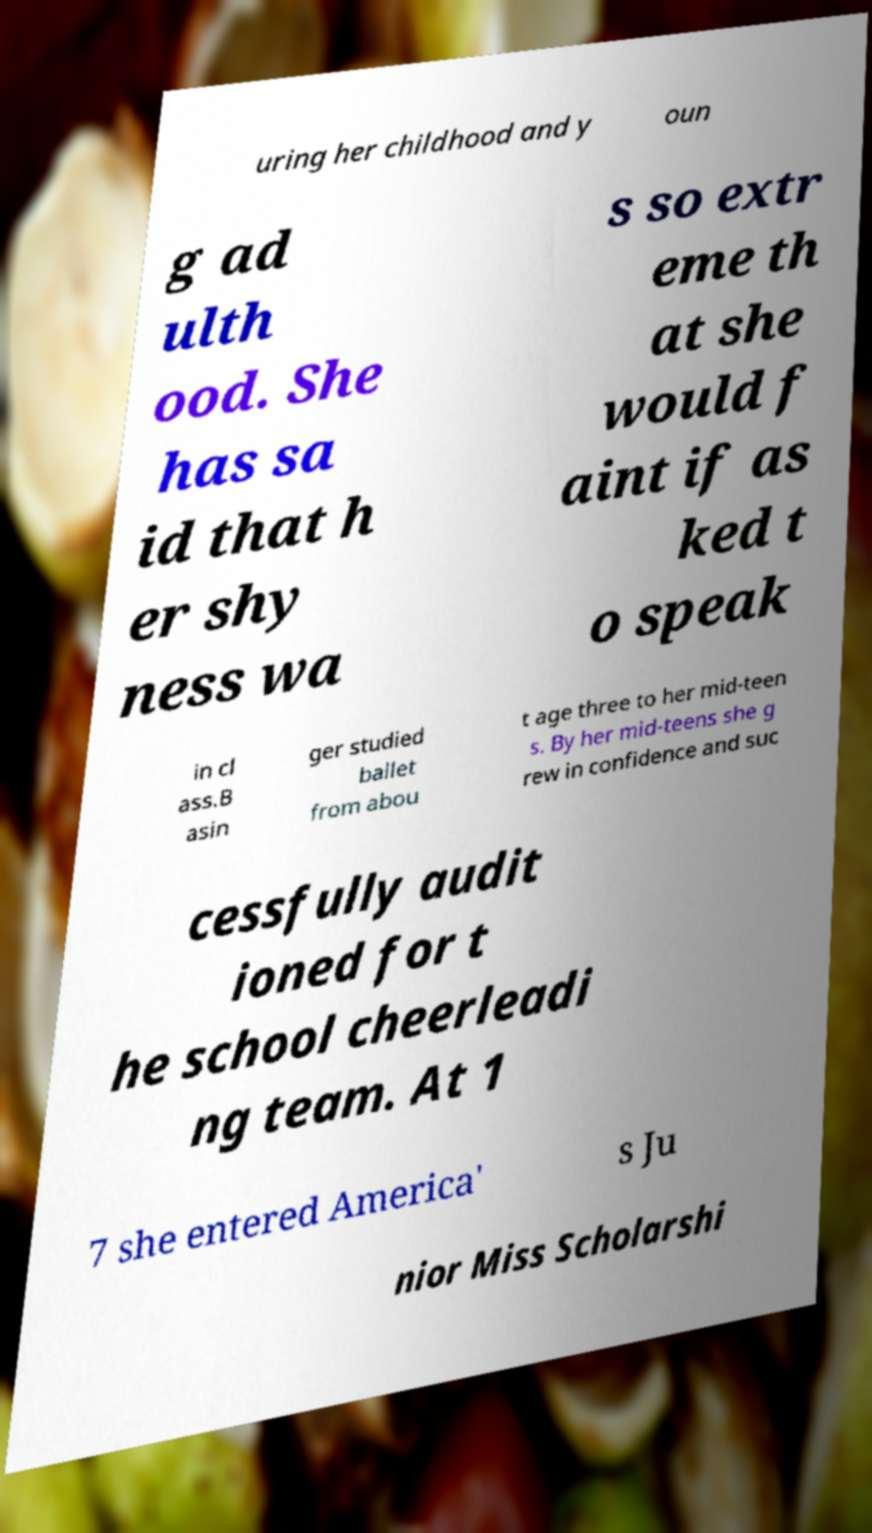Can you read and provide the text displayed in the image?This photo seems to have some interesting text. Can you extract and type it out for me? uring her childhood and y oun g ad ulth ood. She has sa id that h er shy ness wa s so extr eme th at she would f aint if as ked t o speak in cl ass.B asin ger studied ballet from abou t age three to her mid-teen s. By her mid-teens she g rew in confidence and suc cessfully audit ioned for t he school cheerleadi ng team. At 1 7 she entered America' s Ju nior Miss Scholarshi 